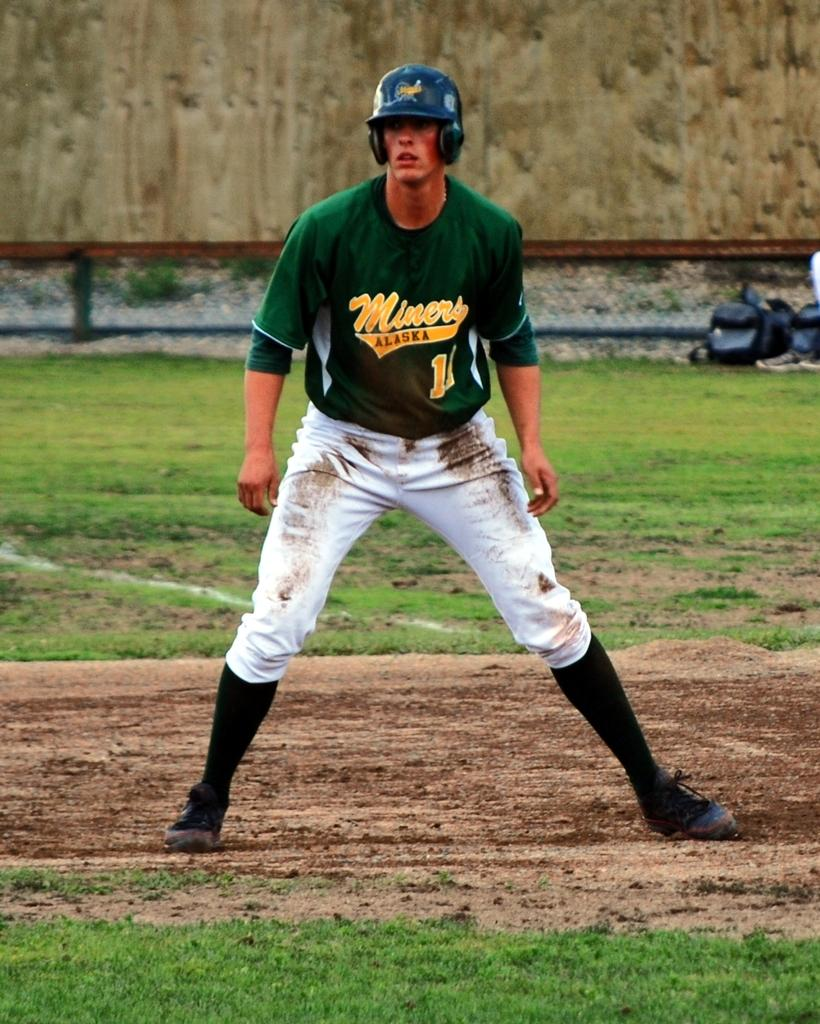Provide a one-sentence caption for the provided image. An Alaska Miners player takes his lead from first base. 